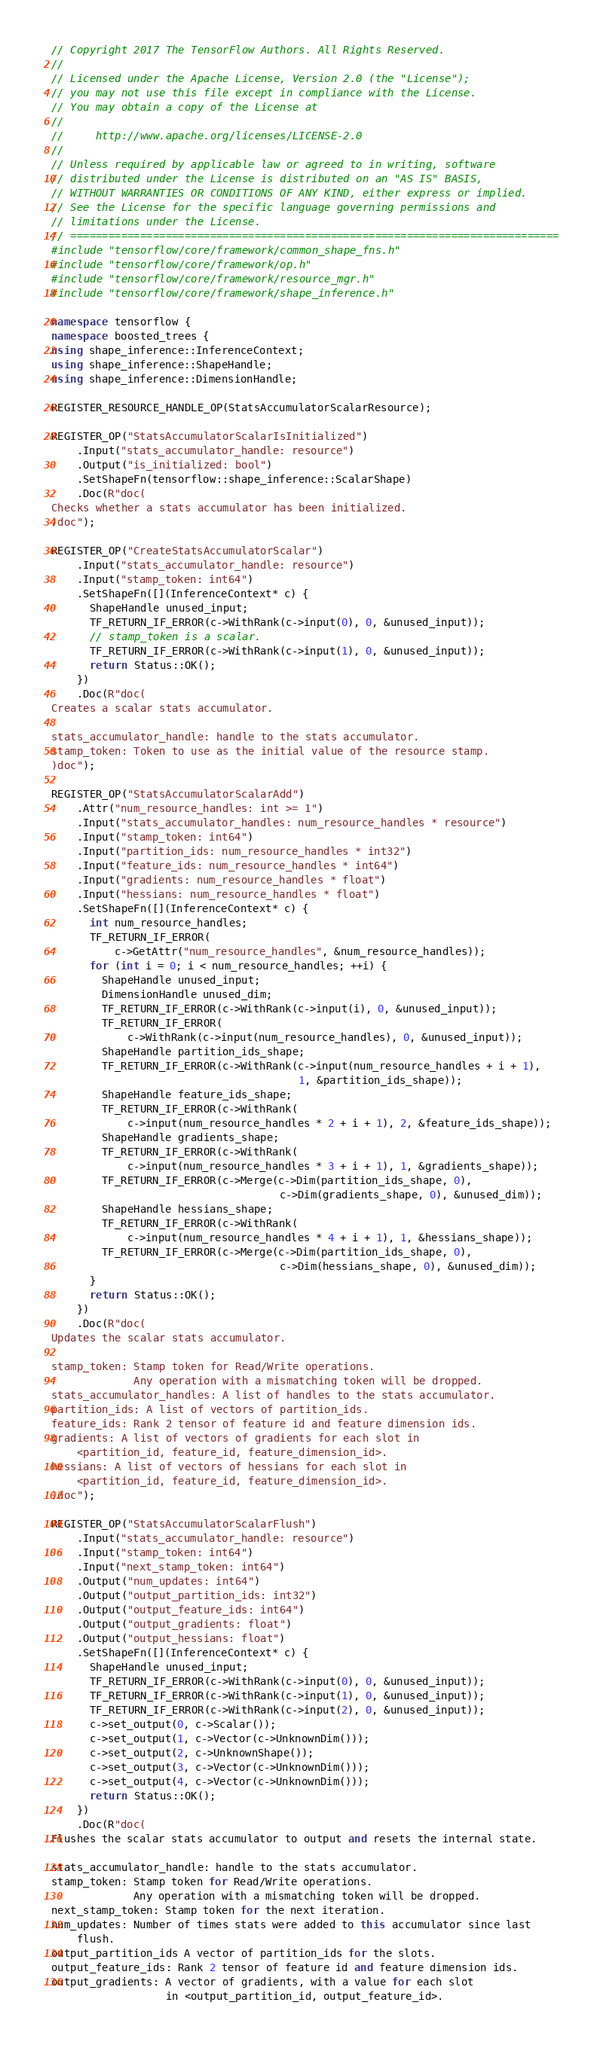Convert code to text. <code><loc_0><loc_0><loc_500><loc_500><_C++_>// Copyright 2017 The TensorFlow Authors. All Rights Reserved.
//
// Licensed under the Apache License, Version 2.0 (the "License");
// you may not use this file except in compliance with the License.
// You may obtain a copy of the License at
//
//     http://www.apache.org/licenses/LICENSE-2.0
//
// Unless required by applicable law or agreed to in writing, software
// distributed under the License is distributed on an "AS IS" BASIS,
// WITHOUT WARRANTIES OR CONDITIONS OF ANY KIND, either express or implied.
// See the License for the specific language governing permissions and
// limitations under the License.
// =============================================================================
#include "tensorflow/core/framework/common_shape_fns.h"
#include "tensorflow/core/framework/op.h"
#include "tensorflow/core/framework/resource_mgr.h"
#include "tensorflow/core/framework/shape_inference.h"

namespace tensorflow {
namespace boosted_trees {
using shape_inference::InferenceContext;
using shape_inference::ShapeHandle;
using shape_inference::DimensionHandle;

REGISTER_RESOURCE_HANDLE_OP(StatsAccumulatorScalarResource);

REGISTER_OP("StatsAccumulatorScalarIsInitialized")
    .Input("stats_accumulator_handle: resource")
    .Output("is_initialized: bool")
    .SetShapeFn(tensorflow::shape_inference::ScalarShape)
    .Doc(R"doc(
Checks whether a stats accumulator has been initialized.
)doc");

REGISTER_OP("CreateStatsAccumulatorScalar")
    .Input("stats_accumulator_handle: resource")
    .Input("stamp_token: int64")
    .SetShapeFn([](InferenceContext* c) {
      ShapeHandle unused_input;
      TF_RETURN_IF_ERROR(c->WithRank(c->input(0), 0, &unused_input));
      // stamp_token is a scalar.
      TF_RETURN_IF_ERROR(c->WithRank(c->input(1), 0, &unused_input));
      return Status::OK();
    })
    .Doc(R"doc(
Creates a scalar stats accumulator.

stats_accumulator_handle: handle to the stats accumulator.
stamp_token: Token to use as the initial value of the resource stamp.
)doc");

REGISTER_OP("StatsAccumulatorScalarAdd")
    .Attr("num_resource_handles: int >= 1")
    .Input("stats_accumulator_handles: num_resource_handles * resource")
    .Input("stamp_token: int64")
    .Input("partition_ids: num_resource_handles * int32")
    .Input("feature_ids: num_resource_handles * int64")
    .Input("gradients: num_resource_handles * float")
    .Input("hessians: num_resource_handles * float")
    .SetShapeFn([](InferenceContext* c) {
      int num_resource_handles;
      TF_RETURN_IF_ERROR(
          c->GetAttr("num_resource_handles", &num_resource_handles));
      for (int i = 0; i < num_resource_handles; ++i) {
        ShapeHandle unused_input;
        DimensionHandle unused_dim;
        TF_RETURN_IF_ERROR(c->WithRank(c->input(i), 0, &unused_input));
        TF_RETURN_IF_ERROR(
            c->WithRank(c->input(num_resource_handles), 0, &unused_input));
        ShapeHandle partition_ids_shape;
        TF_RETURN_IF_ERROR(c->WithRank(c->input(num_resource_handles + i + 1),
                                       1, &partition_ids_shape));
        ShapeHandle feature_ids_shape;
        TF_RETURN_IF_ERROR(c->WithRank(
            c->input(num_resource_handles * 2 + i + 1), 2, &feature_ids_shape));
        ShapeHandle gradients_shape;
        TF_RETURN_IF_ERROR(c->WithRank(
            c->input(num_resource_handles * 3 + i + 1), 1, &gradients_shape));
        TF_RETURN_IF_ERROR(c->Merge(c->Dim(partition_ids_shape, 0),
                                    c->Dim(gradients_shape, 0), &unused_dim));
        ShapeHandle hessians_shape;
        TF_RETURN_IF_ERROR(c->WithRank(
            c->input(num_resource_handles * 4 + i + 1), 1, &hessians_shape));
        TF_RETURN_IF_ERROR(c->Merge(c->Dim(partition_ids_shape, 0),
                                    c->Dim(hessians_shape, 0), &unused_dim));
      }
      return Status::OK();
    })
    .Doc(R"doc(
Updates the scalar stats accumulator.

stamp_token: Stamp token for Read/Write operations.
             Any operation with a mismatching token will be dropped.
stats_accumulator_handles: A list of handles to the stats accumulator.
partition_ids: A list of vectors of partition_ids.
feature_ids: Rank 2 tensor of feature id and feature dimension ids.
gradients: A list of vectors of gradients for each slot in
    <partition_id, feature_id, feature_dimension_id>.
hessians: A list of vectors of hessians for each slot in
    <partition_id, feature_id, feature_dimension_id>.
)doc");

REGISTER_OP("StatsAccumulatorScalarFlush")
    .Input("stats_accumulator_handle: resource")
    .Input("stamp_token: int64")
    .Input("next_stamp_token: int64")
    .Output("num_updates: int64")
    .Output("output_partition_ids: int32")
    .Output("output_feature_ids: int64")
    .Output("output_gradients: float")
    .Output("output_hessians: float")
    .SetShapeFn([](InferenceContext* c) {
      ShapeHandle unused_input;
      TF_RETURN_IF_ERROR(c->WithRank(c->input(0), 0, &unused_input));
      TF_RETURN_IF_ERROR(c->WithRank(c->input(1), 0, &unused_input));
      TF_RETURN_IF_ERROR(c->WithRank(c->input(2), 0, &unused_input));
      c->set_output(0, c->Scalar());
      c->set_output(1, c->Vector(c->UnknownDim()));
      c->set_output(2, c->UnknownShape());
      c->set_output(3, c->Vector(c->UnknownDim()));
      c->set_output(4, c->Vector(c->UnknownDim()));
      return Status::OK();
    })
    .Doc(R"doc(
Flushes the scalar stats accumulator to output and resets the internal state.

stats_accumulator_handle: handle to the stats accumulator.
stamp_token: Stamp token for Read/Write operations.
             Any operation with a mismatching token will be dropped.
next_stamp_token: Stamp token for the next iteration.
num_updates: Number of times stats were added to this accumulator since last
    flush.
output_partition_ids A vector of partition_ids for the slots.
output_feature_ids: Rank 2 tensor of feature id and feature dimension ids.
output_gradients: A vector of gradients, with a value for each slot
                  in <output_partition_id, output_feature_id>.</code> 